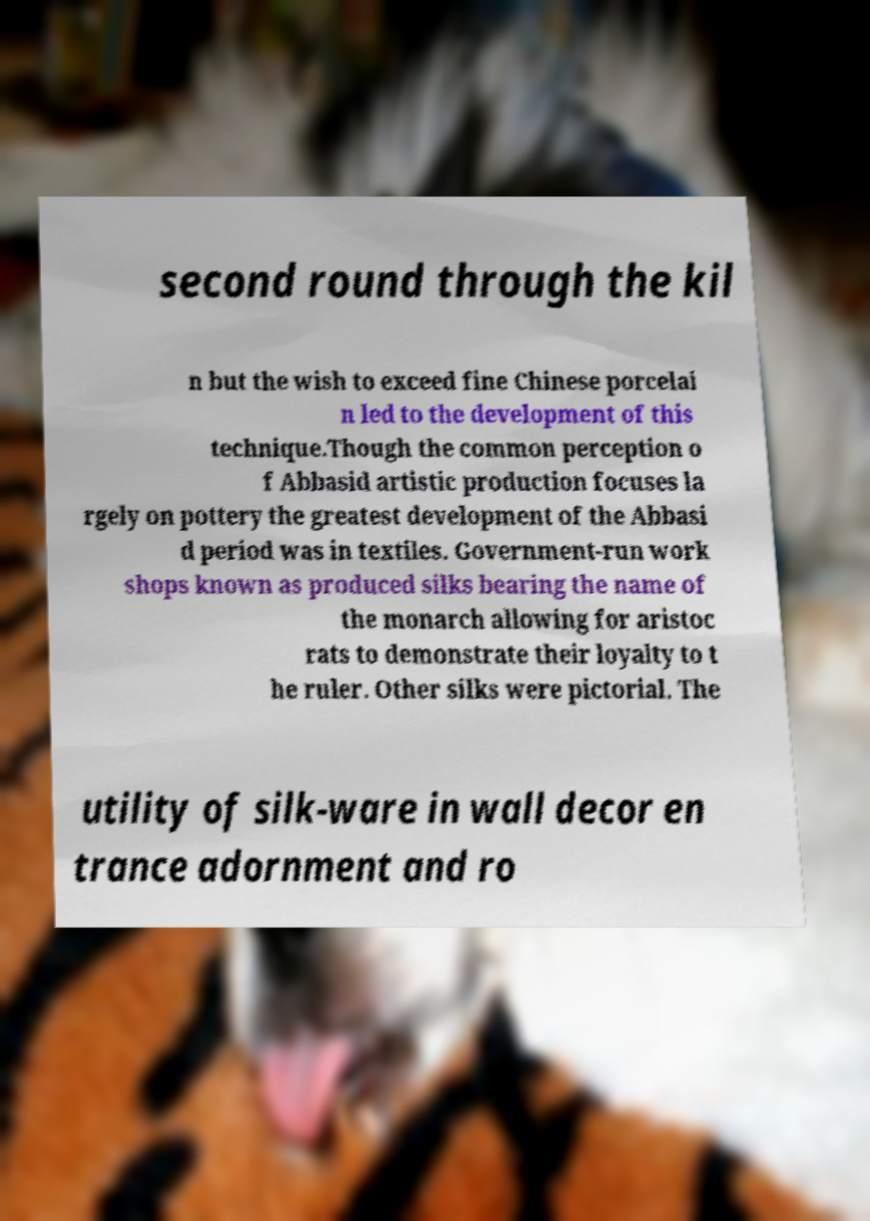For documentation purposes, I need the text within this image transcribed. Could you provide that? second round through the kil n but the wish to exceed fine Chinese porcelai n led to the development of this technique.Though the common perception o f Abbasid artistic production focuses la rgely on pottery the greatest development of the Abbasi d period was in textiles. Government-run work shops known as produced silks bearing the name of the monarch allowing for aristoc rats to demonstrate their loyalty to t he ruler. Other silks were pictorial. The utility of silk-ware in wall decor en trance adornment and ro 